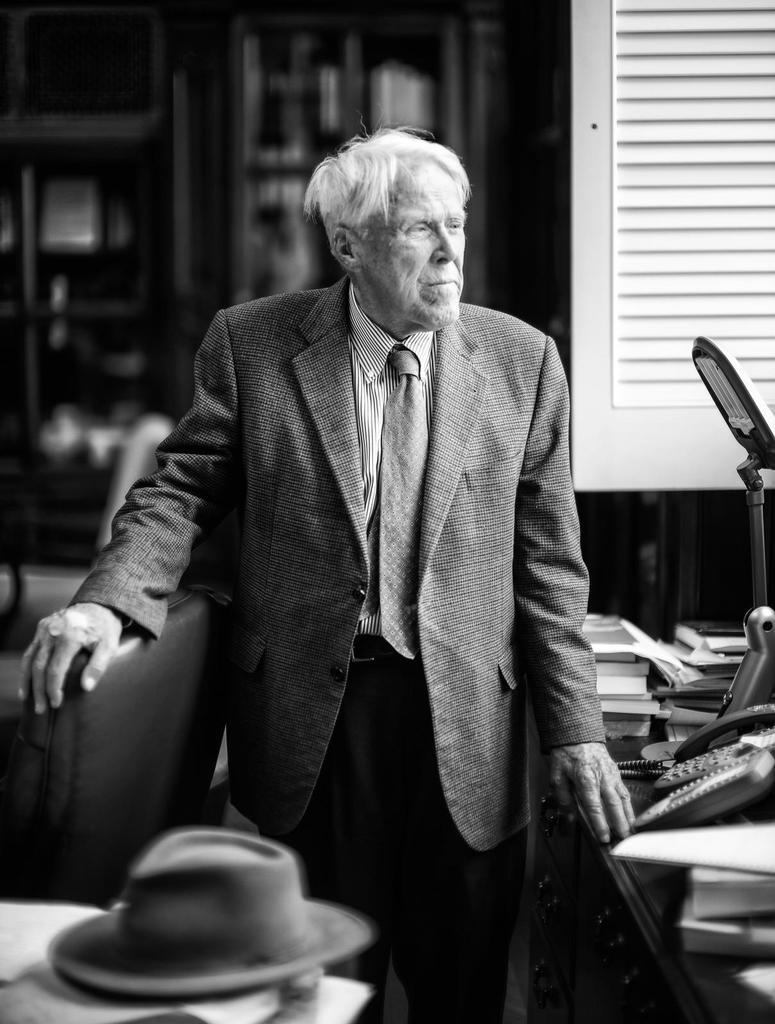Who is present in the image? There is a man in the image. What objects are in front of the man? There are telephones and books in front of the man. What type of light is visible in the image? There is a light in front of the man. What item is placed on a table in the image? There is a cap on a table in the image. What type of eggnog is being served in the image? There is no eggnog present in the image. How does the man's stomach feel in the image? The image does not provide any information about the man's stomach or how he might be feeling. --- Facts: 1. There is a car in the image. 2. The car is red. 3. The car has four wheels. 4. There is a road in the image. 5. The road is paved. Absurd Topics: parrot, sand, volcano Conversation: What type of vehicle is in the image? There is a car in the image. What color is the car? The car is red. How many wheels does the car have? The car has four wheels. What type of surface is visible in the image? There is a road in the image, and it is paved. Reasoning: Let's think step by step in order to produce the conversation. We start by identifying the main subject in the image, which is the car. Then, we expand the conversation to include other details about the car, such as its color and the number of wheels. Finally, we describe the road in the image, noting that it is paved. Each question is designed to elicit a specific detail about the image that is known from the provided facts. Absurd Question/Answer: Can you see a parrot perched on the car's hood in the image? No, there is no parrot present in the image. Is there a volcano visible in the background of the image? No, there is no volcano present in the image. 